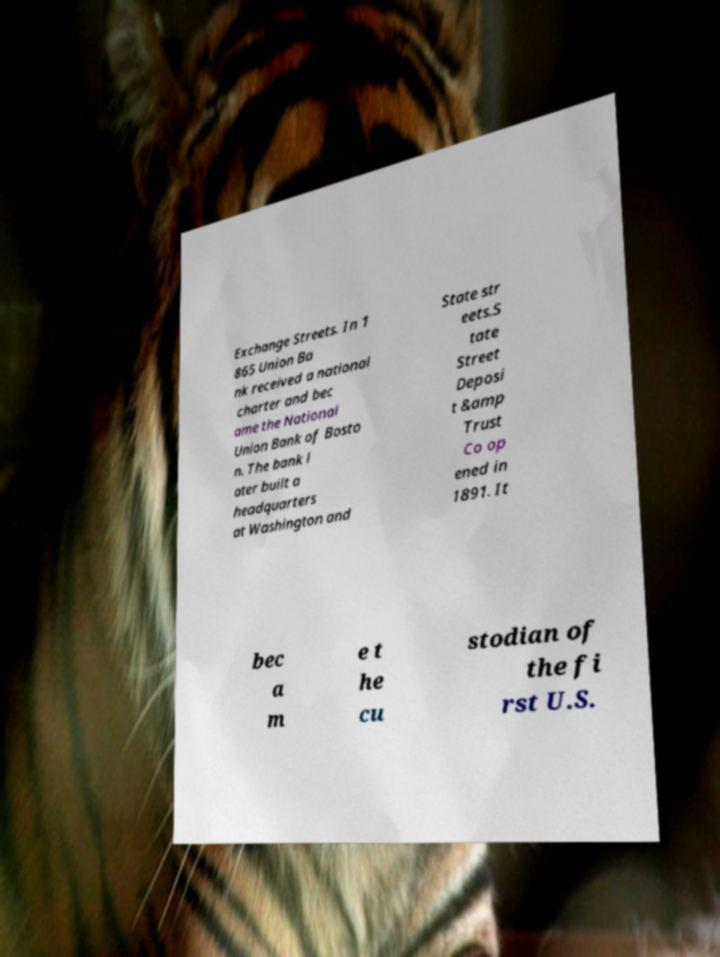For documentation purposes, I need the text within this image transcribed. Could you provide that? Exchange Streets. In 1 865 Union Ba nk received a national charter and bec ame the National Union Bank of Bosto n. The bank l ater built a headquarters at Washington and State str eets.S tate Street Deposi t &amp Trust Co op ened in 1891. It bec a m e t he cu stodian of the fi rst U.S. 